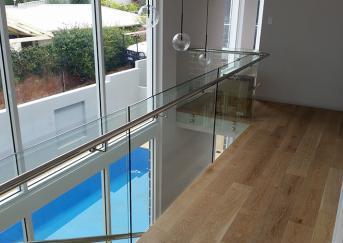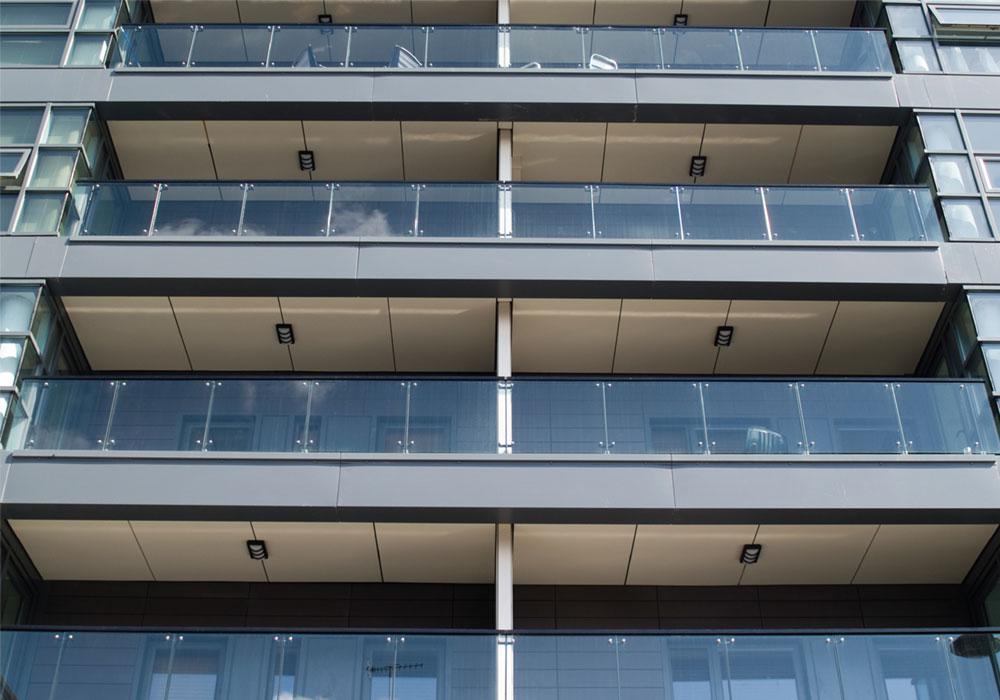The first image is the image on the left, the second image is the image on the right. Assess this claim about the two images: "A building with at least 3 stories has glass deck railings outside.". Correct or not? Answer yes or no. Yes. The first image is the image on the left, the second image is the image on the right. Evaluate the accuracy of this statement regarding the images: "The right image contains at least three balconies on a building.". Is it true? Answer yes or no. Yes. 